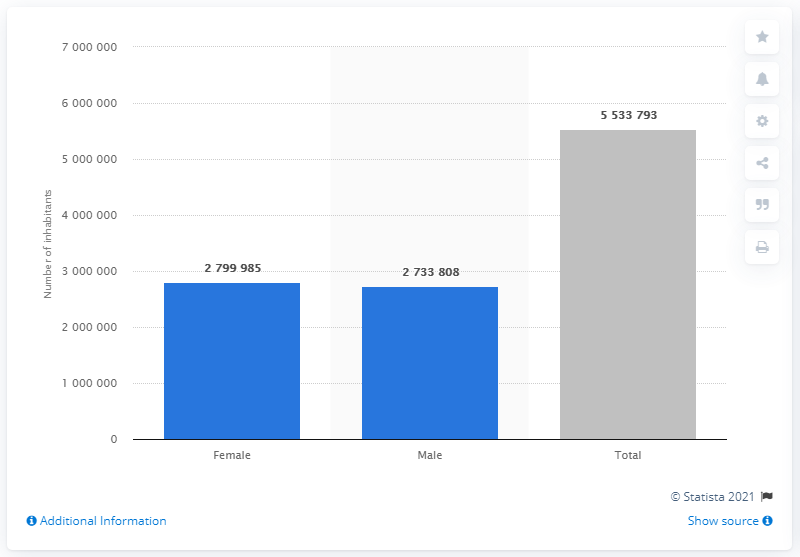Indicate a few pertinent items in this graphic. It is estimated that 273,3808 men currently reside in Finland. According to estimates, the population of Finland in 2020 was approximately 55,337,930. The population of Finland consists of approximately 2799985 women, according to the latest estimates. 